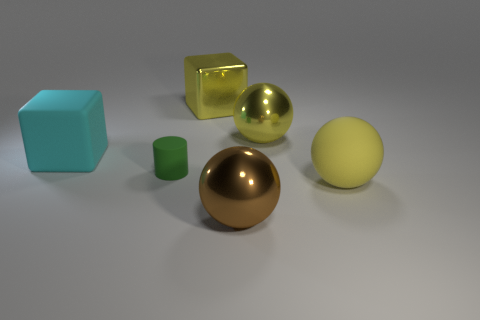Add 1 blocks. How many objects exist? 7 Subtract all cylinders. How many objects are left? 5 Add 4 big matte spheres. How many big matte spheres exist? 5 Subtract 0 green blocks. How many objects are left? 6 Subtract all tiny yellow matte spheres. Subtract all large yellow metallic things. How many objects are left? 4 Add 5 shiny spheres. How many shiny spheres are left? 7 